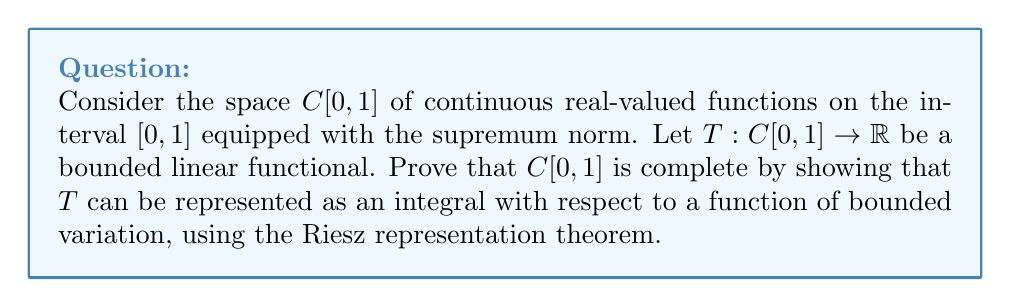Can you solve this math problem? To prove the completeness of $C[0,1]$ using the Riesz representation theorem, we'll follow these steps:

1) First, recall the Riesz representation theorem: For any bounded linear functional $T$ on $C[0,1]$, there exists a unique function $\alpha$ of bounded variation on $[0,1]$ such that:

   $$T(f) = \int_0^1 f(x) d\alpha(x)$$

   for all $f \in C[0,1]$.

2) Now, let's consider a Cauchy sequence $\{f_n\}$ in $C[0,1]$ with respect to the supremum norm. We need to show that this sequence converges to a function in $C[0,1]$.

3) For any $\epsilon > 0$, there exists an $N$ such that for all $m, n > N$:

   $$\sup_{x \in [0,1]} |f_m(x) - f_n(x)| < \epsilon$$

4) This implies that for each $x \in [0,1]$, $\{f_n(x)\}$ is a Cauchy sequence in $\mathbb{R}$. Since $\mathbb{R}$ is complete, this sequence converges to some value, say $f(x)$.

5) Define $f: [0,1] \rightarrow \mathbb{R}$ by $f(x) = \lim_{n \to \infty} f_n(x)$.

6) We need to show that $f$ is continuous and that $f_n$ converges uniformly to $f$.

7) For continuity, let $x, y \in [0,1]$. Then:

   $$|f(x) - f(y)| \leq |f(x) - f_n(x)| + |f_n(x) - f_n(y)| + |f_n(y) - f(y)|$$

   The first and third terms can be made arbitrarily small by choosing large $n$, and the middle term is small for $x$ close to $y$ due to the continuity of $f_n$. This proves $f$ is continuous.

8) For uniform convergence, we can use the Cauchy criterion. For any $\epsilon > 0$, choose $N$ as in step 3. Then for all $x \in [0,1]$ and $n > N$:

   $$|f(x) - f_n(x)| = \lim_{m \to \infty} |f_m(x) - f_n(x)| \leq \epsilon$$

   This proves uniform convergence.

9) Therefore, $f \in C[0,1]$ and $f_n$ converges to $f$ in the supremum norm.

10) We have shown that every Cauchy sequence in $C[0,1]$ converges to an element of $C[0,1]$, which proves that $C[0,1]$ is complete.

The Riesz representation theorem played a crucial role in this proof by guaranteeing that every bounded linear functional on $C[0,1]$ has an integral representation. This property is closely related to the completeness of $C[0,1]$.
Answer: $C[0,1]$ is complete. Every Cauchy sequence in $C[0,1]$ converges to a continuous function on $[0,1]$ in the supremum norm. 